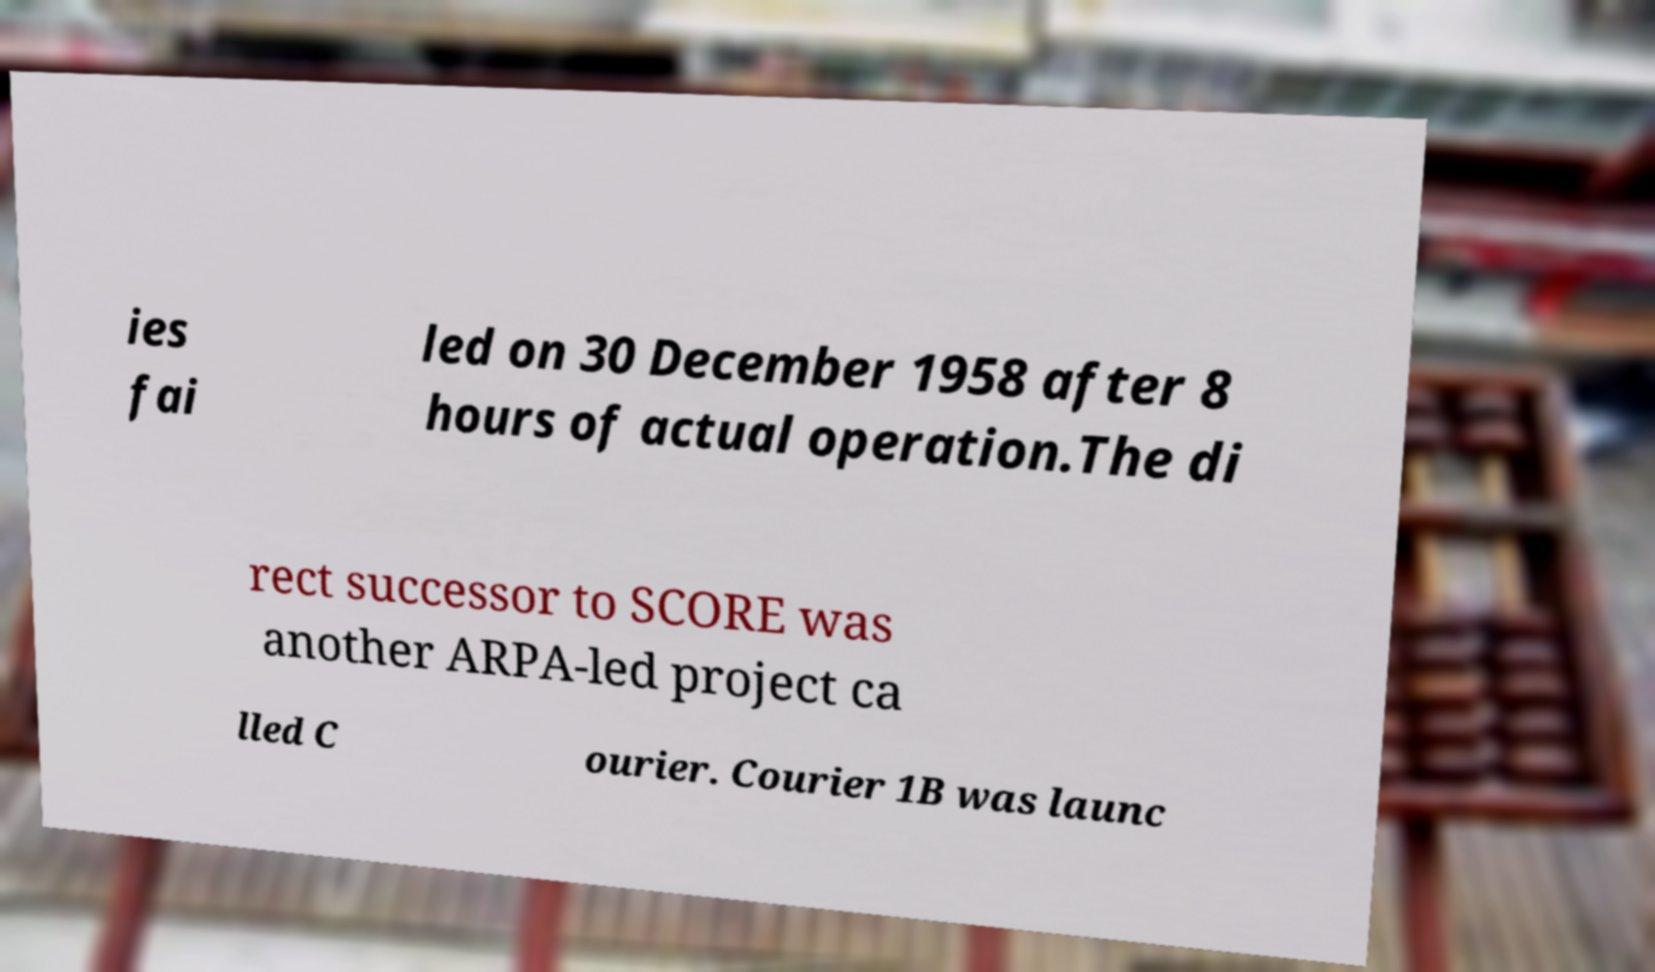Please read and relay the text visible in this image. What does it say? ies fai led on 30 December 1958 after 8 hours of actual operation.The di rect successor to SCORE was another ARPA-led project ca lled C ourier. Courier 1B was launc 